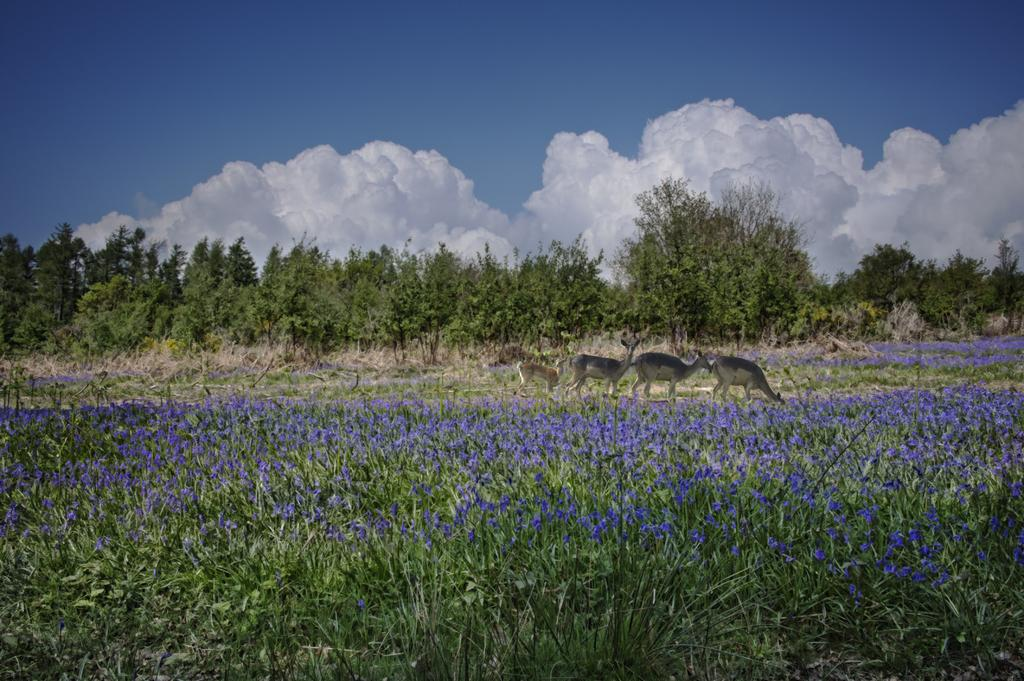What is the main subject of the image? The main subject of the image is the plants with beautiful purple flowers. Can you describe the plants in the image? Yes, the plants have many beautiful purple flowers. What can be seen in the background of the image? In the background, there is a group of animals and a lot of trees. What type of discovery was made during the meal in the image? There is no meal or discovery present in the image; it features plants with purple flowers and a background with animals and trees. 